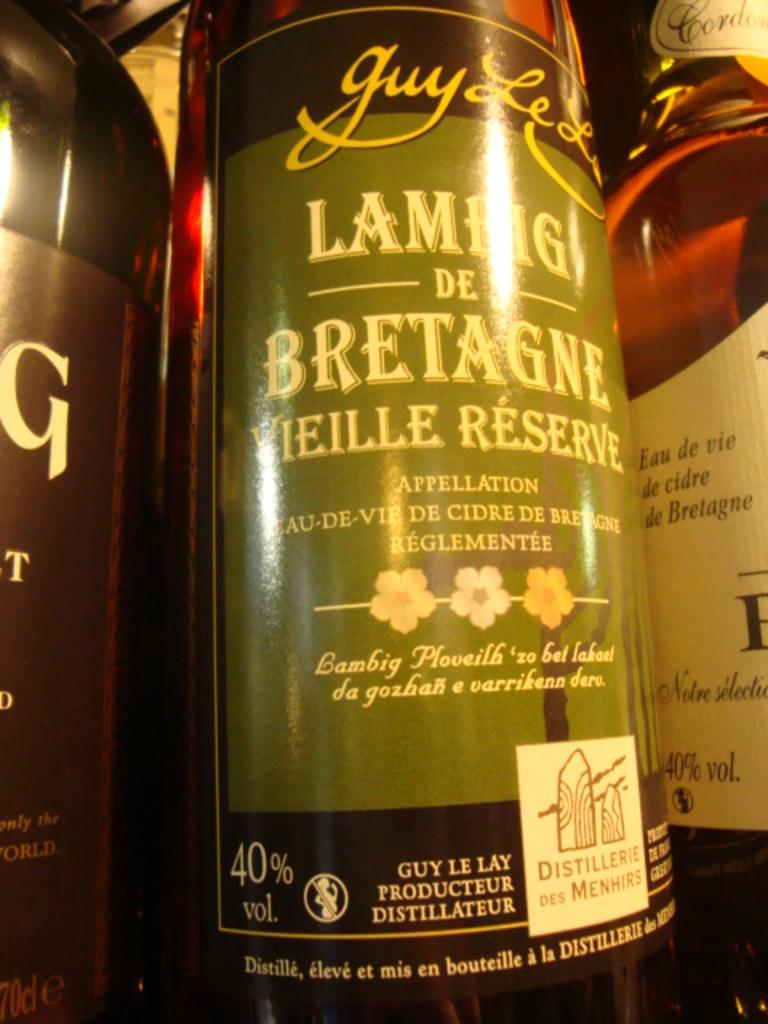<image>
Provide a brief description of the given image. A bottle of wine that is called Lamhg De Bretagne Vieille Reserve. 